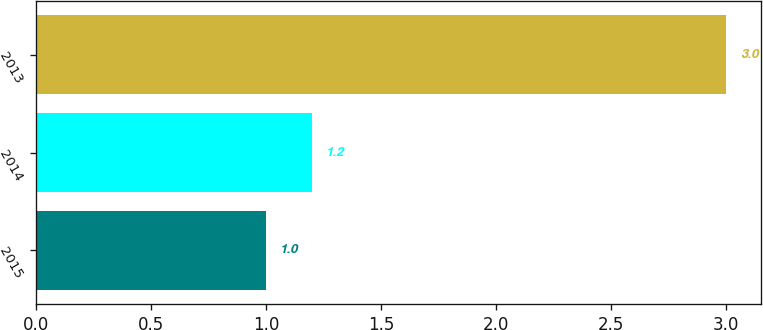<chart> <loc_0><loc_0><loc_500><loc_500><bar_chart><fcel>2015<fcel>2014<fcel>2013<nl><fcel>1<fcel>1.2<fcel>3<nl></chart> 